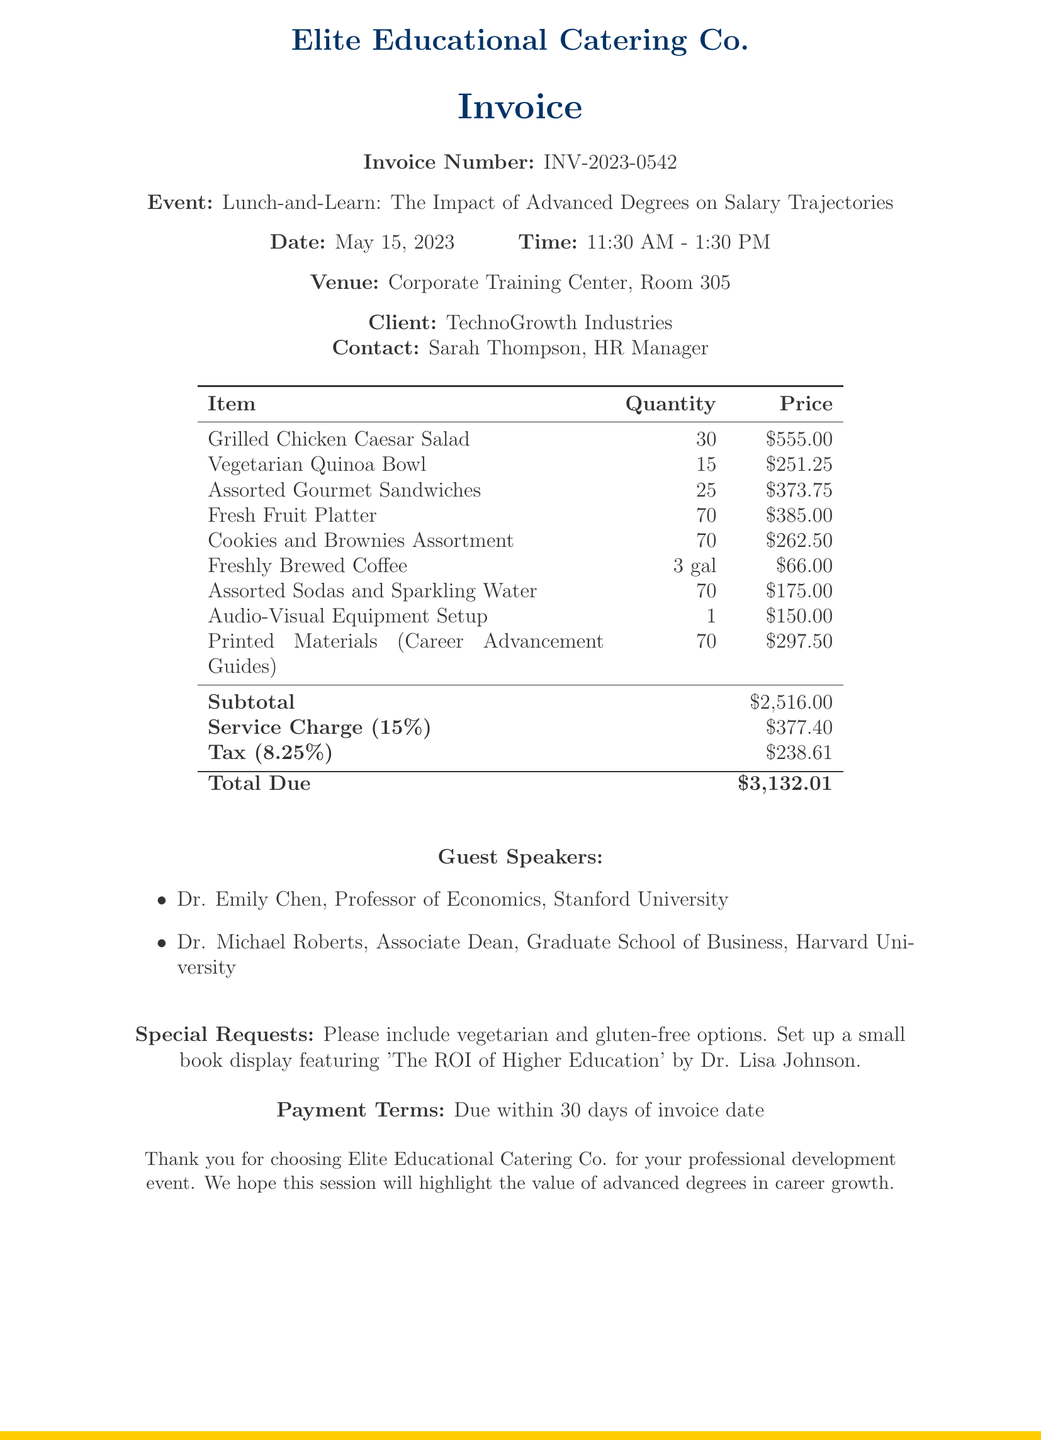What is the invoice number? The invoice number is specifically mentioned in the document as an identification for the transaction.
Answer: INV-2023-0542 What is the total due amount? The total due amount is the final calculated figure that the client needs to pay, including all charges.
Answer: $3581.84 Who are the guest speakers? The document lists the names and titles of the guest speakers contributing to the event.
Answer: Dr. Emily Chen, Dr. Michael Roberts What is the date of the event? The document specifies the date when the event will take place.
Answer: May 15, 2023 What is the service charge percentage? The service charge percentage is noted to clarify the added charges based on the subtotal.
Answer: 15% How many vegetarian bowls were ordered? The quantity of vegetarian options ordered is relevant for understanding dietary considerations for the event.
Answer: 15 What special requests were made? Special requests are outlined to ensure specific needs are met during the catering event.
Answer: vegetarian and gluten-free options What venue is the event held at? The venue provides information about the location where the event is hosted.
Answer: Corporate Training Center, Room 305 What payment terms are specified? Payment terms provide clarity on when the payment is expected from the client.
Answer: Due within 30 days of invoice date 